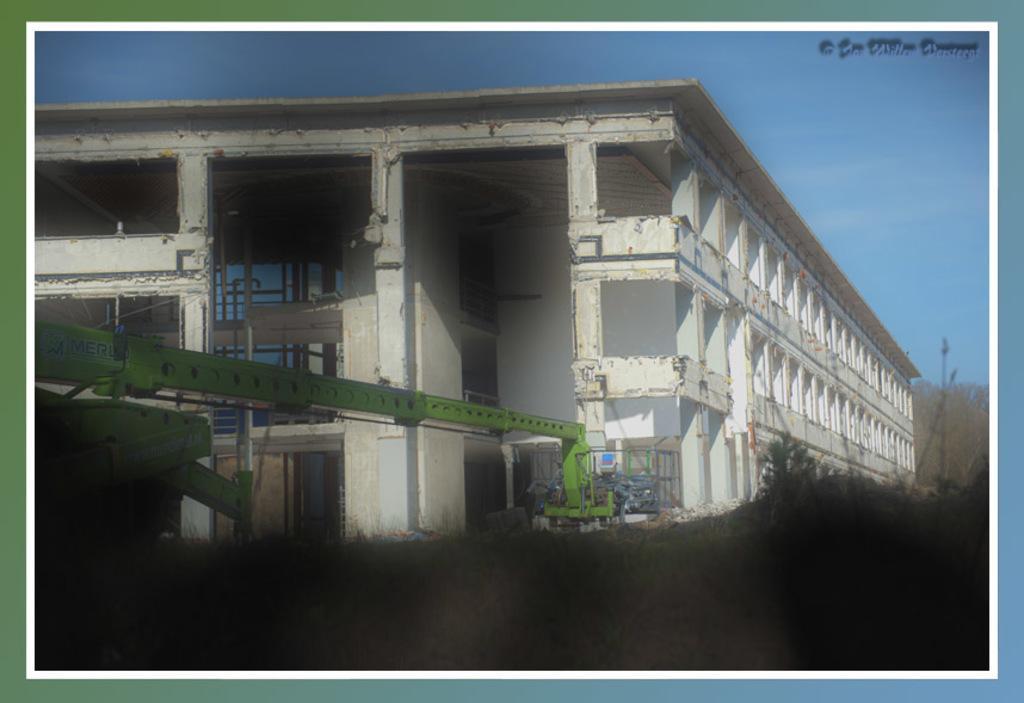Please provide a concise description of this image. In this image I can see the crane in green color, background I can see the building in white color, trees in green color and the sky is in blue color. 